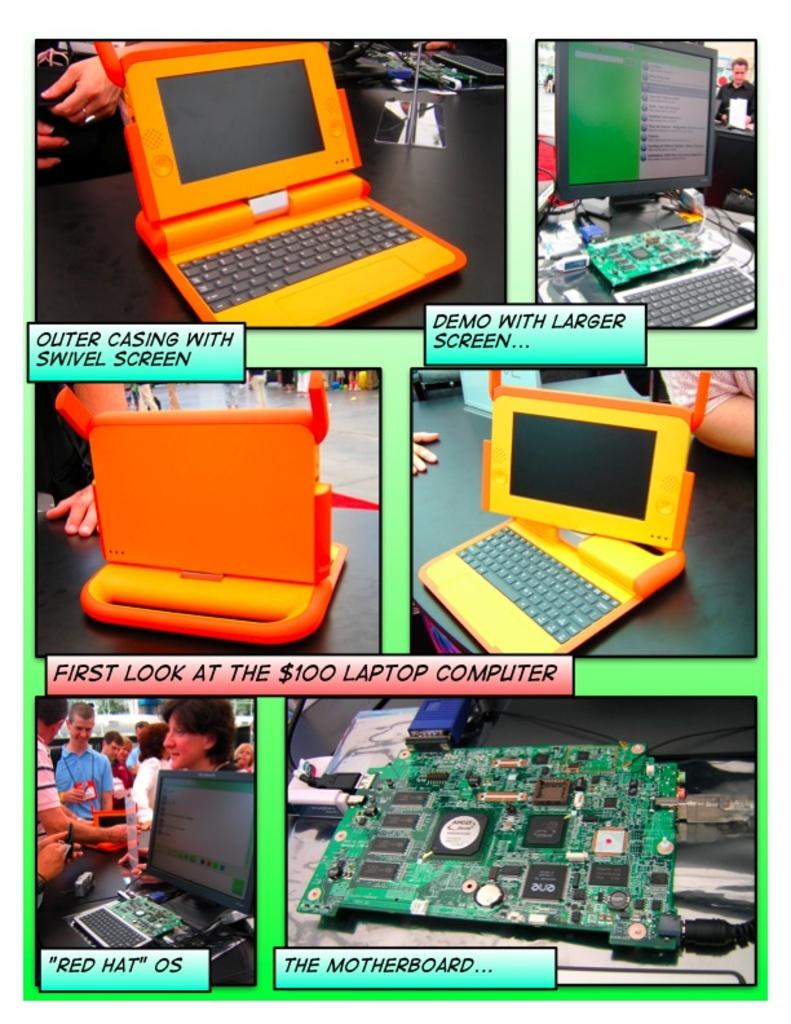What does the red caption say?
Make the answer very short. First look at the $100 laptop computer. What is the title of product at the bottom?
Offer a very short reply. The motherboard. 